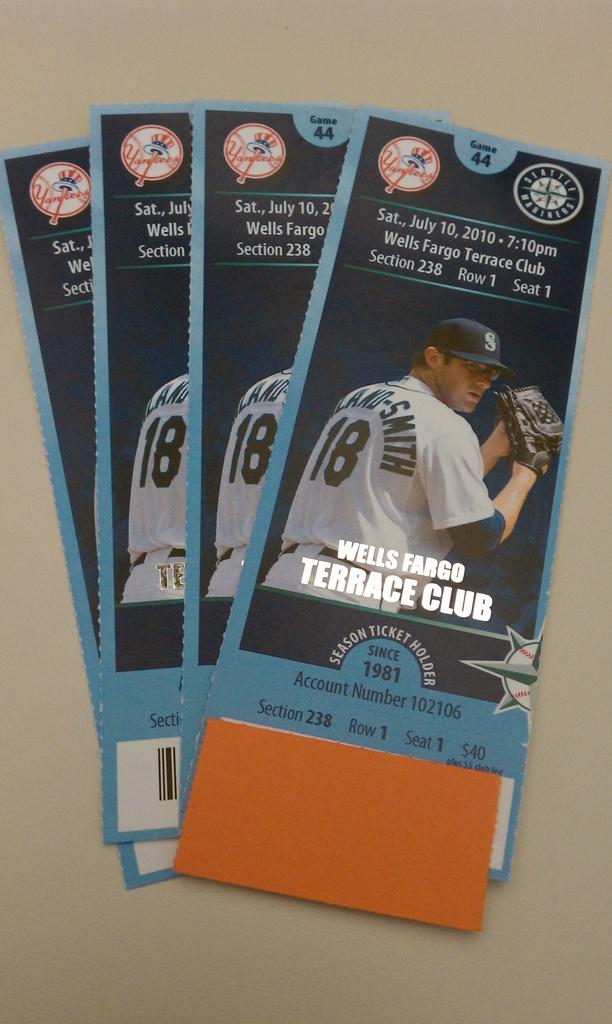What club is the event at?
Offer a terse response. Terrace club. 